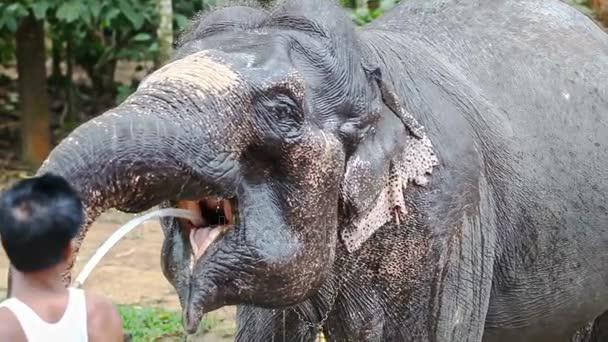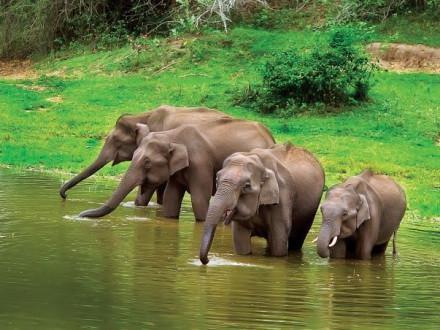The first image is the image on the left, the second image is the image on the right. Evaluate the accuracy of this statement regarding the images: "An image shows a person interacting with one elephant.". Is it true? Answer yes or no. Yes. The first image is the image on the left, the second image is the image on the right. For the images displayed, is the sentence "There are no more than 4 elephants in total." factually correct? Answer yes or no. No. 